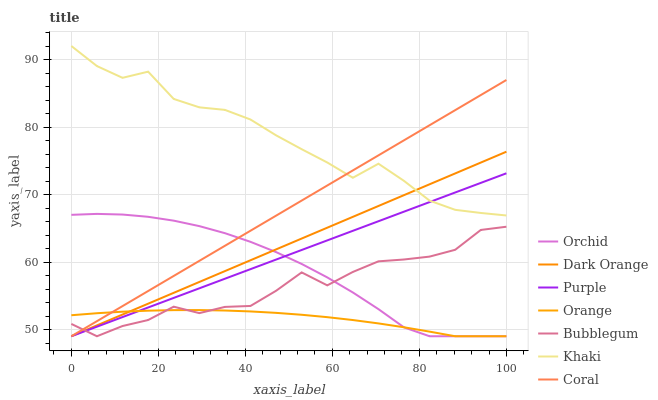Does Orange have the minimum area under the curve?
Answer yes or no. Yes. Does Khaki have the maximum area under the curve?
Answer yes or no. Yes. Does Purple have the minimum area under the curve?
Answer yes or no. No. Does Purple have the maximum area under the curve?
Answer yes or no. No. Is Purple the smoothest?
Answer yes or no. Yes. Is Bubblegum the roughest?
Answer yes or no. Yes. Is Khaki the smoothest?
Answer yes or no. No. Is Khaki the roughest?
Answer yes or no. No. Does Dark Orange have the lowest value?
Answer yes or no. Yes. Does Khaki have the lowest value?
Answer yes or no. No. Does Khaki have the highest value?
Answer yes or no. Yes. Does Purple have the highest value?
Answer yes or no. No. Is Orange less than Khaki?
Answer yes or no. Yes. Is Khaki greater than Orchid?
Answer yes or no. Yes. Does Dark Orange intersect Coral?
Answer yes or no. Yes. Is Dark Orange less than Coral?
Answer yes or no. No. Is Dark Orange greater than Coral?
Answer yes or no. No. Does Orange intersect Khaki?
Answer yes or no. No. 